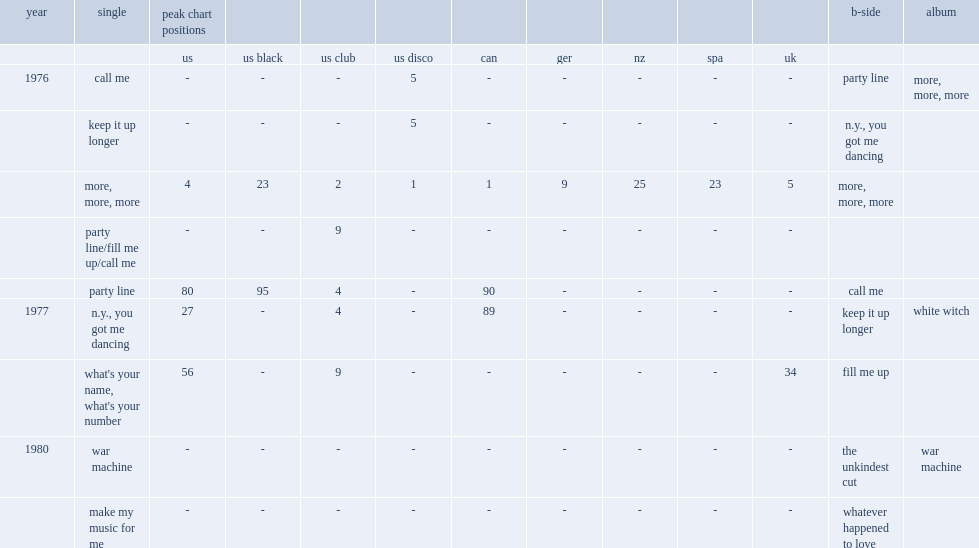What was the rank of andrea true's "more, more, more" peaked on the us billboard hot 100? 4.0. What was the rank of andrea true's "more, more, more" peaked on the uk singles chart? 5.0. 